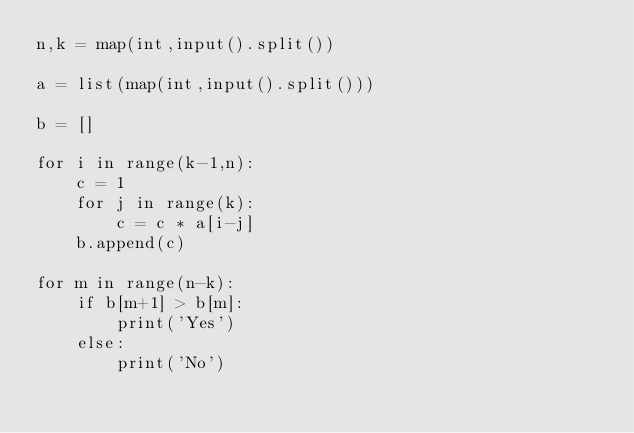Convert code to text. <code><loc_0><loc_0><loc_500><loc_500><_Python_>n,k = map(int,input().split())

a = list(map(int,input().split()))

b = []

for i in range(k-1,n):
    c = 1
    for j in range(k):
        c = c * a[i-j]
    b.append(c)

for m in range(n-k):
    if b[m+1] > b[m]:
        print('Yes')
    else:
        print('No')
</code> 